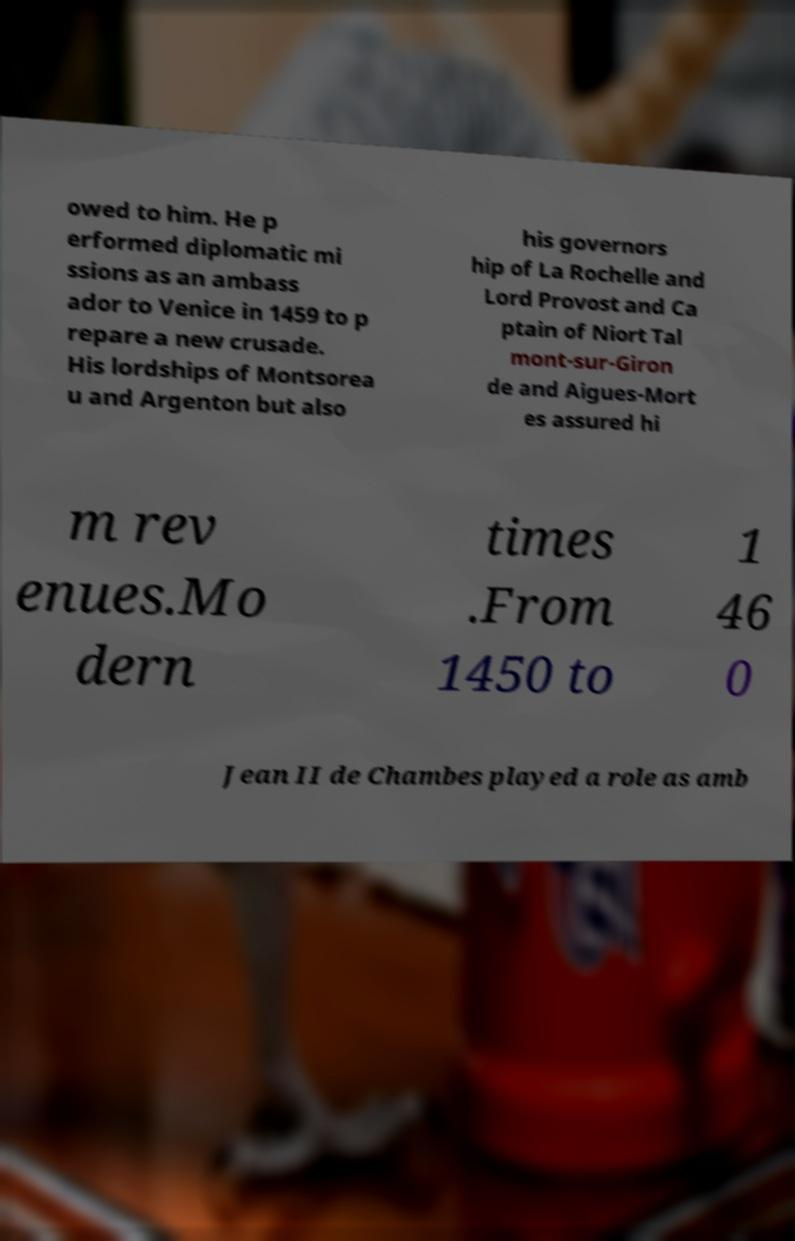There's text embedded in this image that I need extracted. Can you transcribe it verbatim? owed to him. He p erformed diplomatic mi ssions as an ambass ador to Venice in 1459 to p repare a new crusade. His lordships of Montsorea u and Argenton but also his governors hip of La Rochelle and Lord Provost and Ca ptain of Niort Tal mont-sur-Giron de and Aigues-Mort es assured hi m rev enues.Mo dern times .From 1450 to 1 46 0 Jean II de Chambes played a role as amb 